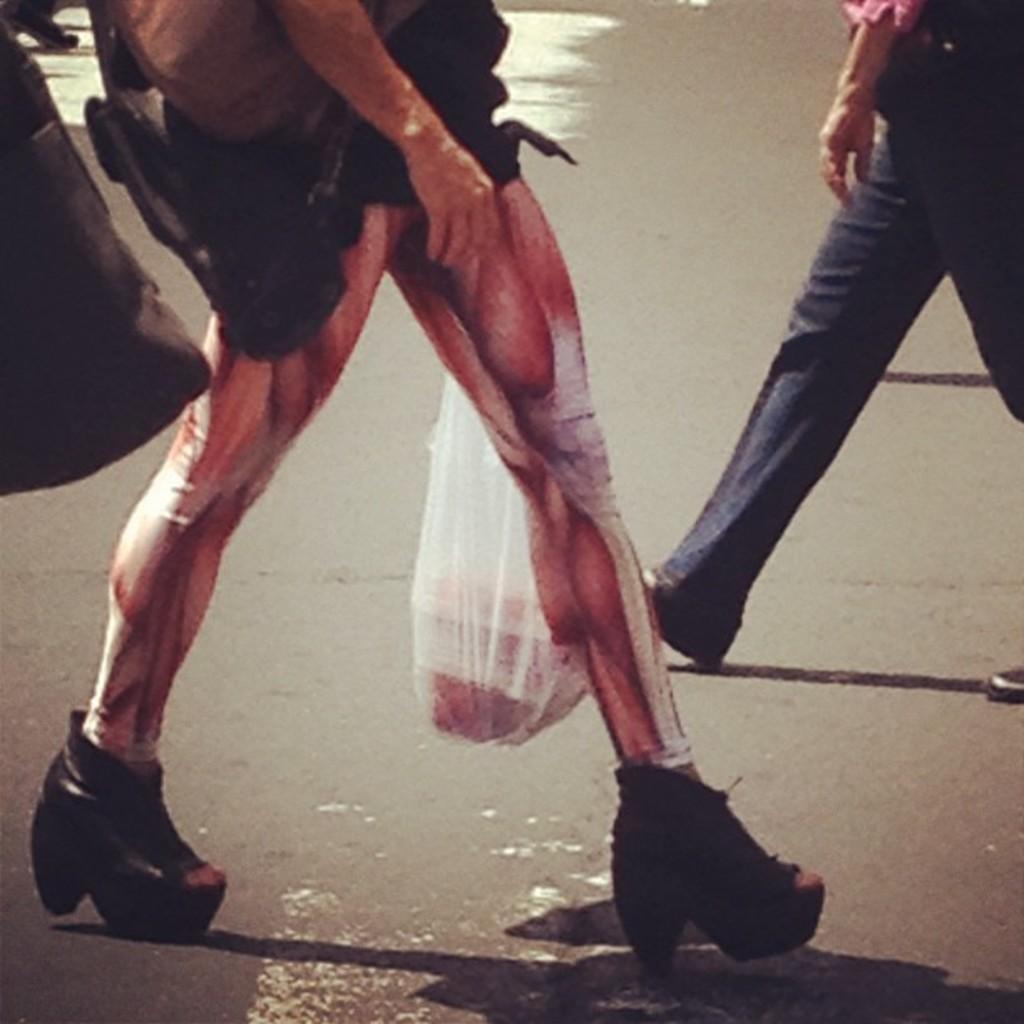Can you describe this image briefly? In this picture there is a man in the center of the image. 